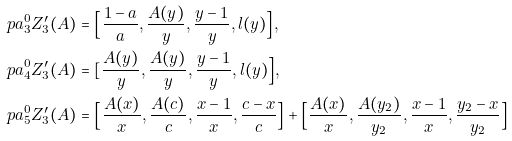Convert formula to latex. <formula><loc_0><loc_0><loc_500><loc_500>\ p a _ { 3 } ^ { 0 } Z _ { 3 } ^ { \prime } ( A ) & = \Big [ \frac { 1 - a } { a } , \frac { A ( y ) } { y } , \frac { y - 1 } { y } , l ( y ) \Big ] , \\ \ p a _ { 4 } ^ { 0 } Z _ { 3 } ^ { \prime } ( A ) & = [ \frac { A ( y ) } { y } , \frac { A ( y ) } { y } , \frac { y - 1 } { y } , l ( y ) \Big ] , \\ \ p a _ { 5 } ^ { 0 } Z _ { 3 } ^ { \prime } ( A ) & = \Big [ \frac { A ( x ) } { x } , \frac { A ( c ) } { c } , \frac { x - 1 } { x } , \frac { c - x } { c } \Big ] + \Big [ \frac { A ( x ) } { x } , \frac { A ( y _ { 2 } ) } { y _ { 2 } } , \frac { x - 1 } { x } , \frac { y _ { 2 } - x } { y _ { 2 } } \Big ]</formula> 